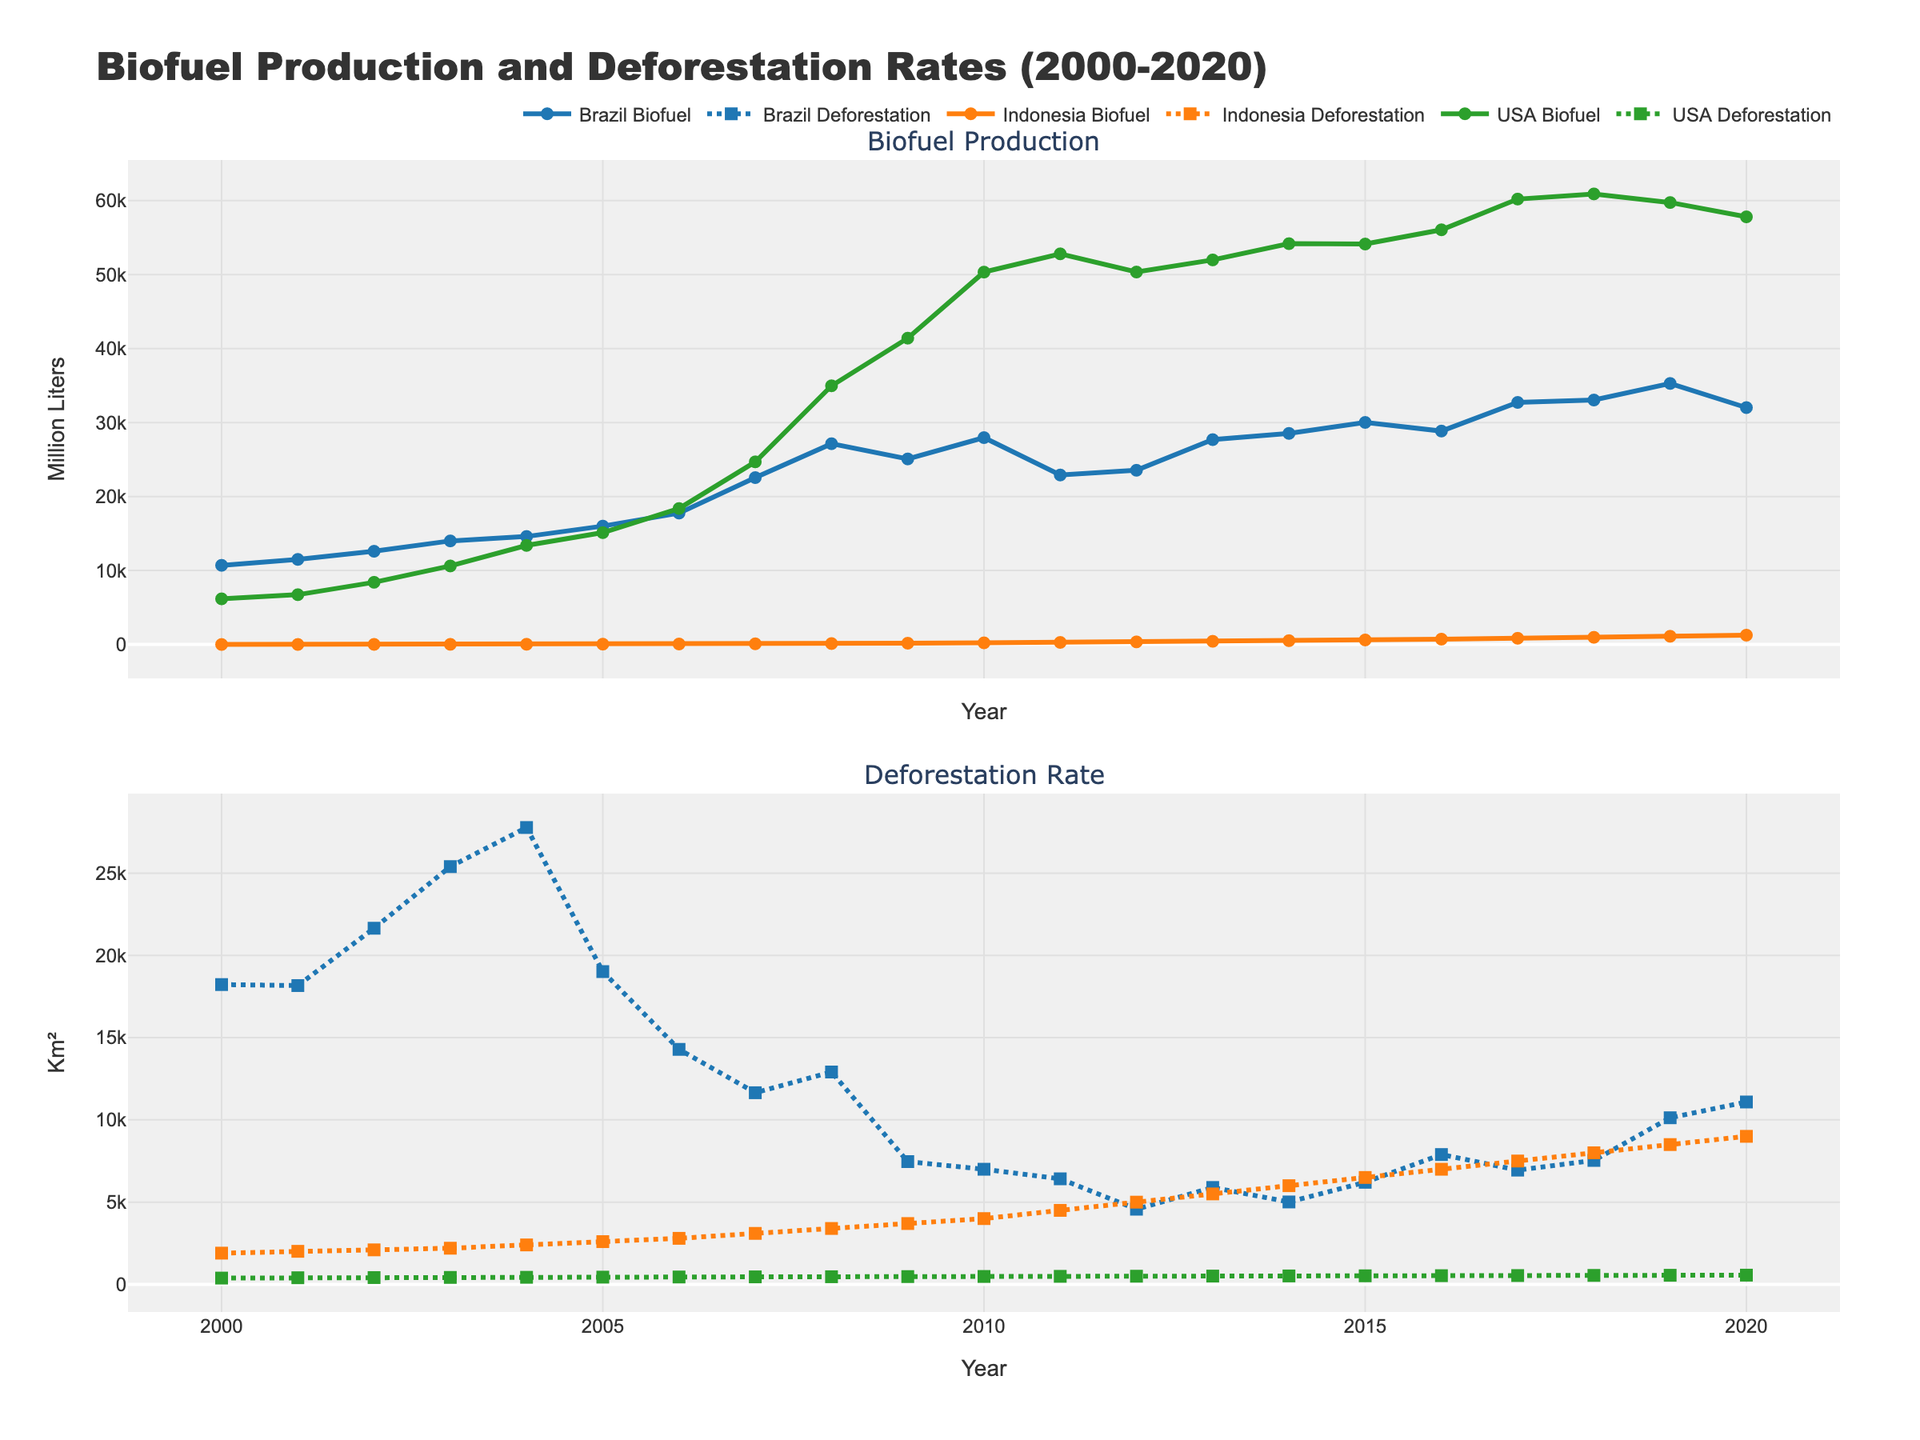What was the highest annual biofuel production in the USA during the period shown? Look at the plot for USA Biofuel Production and identify the peak value.
Answer: 60209 million liters How did Indonesia's deforestation rate change from 2000 to 2020? Observe the trend of the line representing Indonesia's deforestation rate from the start (2000) to the end (2020).
Answer: It increased In which year did Brazil see its maximum deforestation rate? Check the plot for Brazil's Deforestation Rate and find the year with the highest value.
Answer: 2004 Between 2007 and 2014, how did the biofuel production in Brazil generally change? Locate the range for 2007 to 2014 on Brazil's Biofuel Production line chart and observe the general trend.
Answer: It generally increased What is the difference between the highest and lowest deforestation rates in Indonesia shown in the plot? Find the maximum and minimum values of Indonesia's Deforestation Rate and subtract the two.
Answer: 7500 km² Did the USA or Brazil experience a higher increase in biofuel production from 2000 to 2020? Calculate the increase for both countries from their 2000 values to their 2020 values and compare them.
Answer: USA Which country had the most stable biofuel production trend over the period? Look at the lines representing biofuel production for each country and identify which one has the least fluctuation.
Answer: USA When did Indonesia surpass 1000 million liters in biofuel production for the first time? Locate the point in time on Indonesia's Biofuel Production line where it first crosses the 1000 million liters mark.
Answer: 2019 What was the approximate deforestation rate in Brazil in 2007, and how did it compare to the following year? Check the values for Brazil's Deforestation Rate in 2007 and 2008 and compare the two.
Answer: 11651 km² in 2007, higher than 2008 